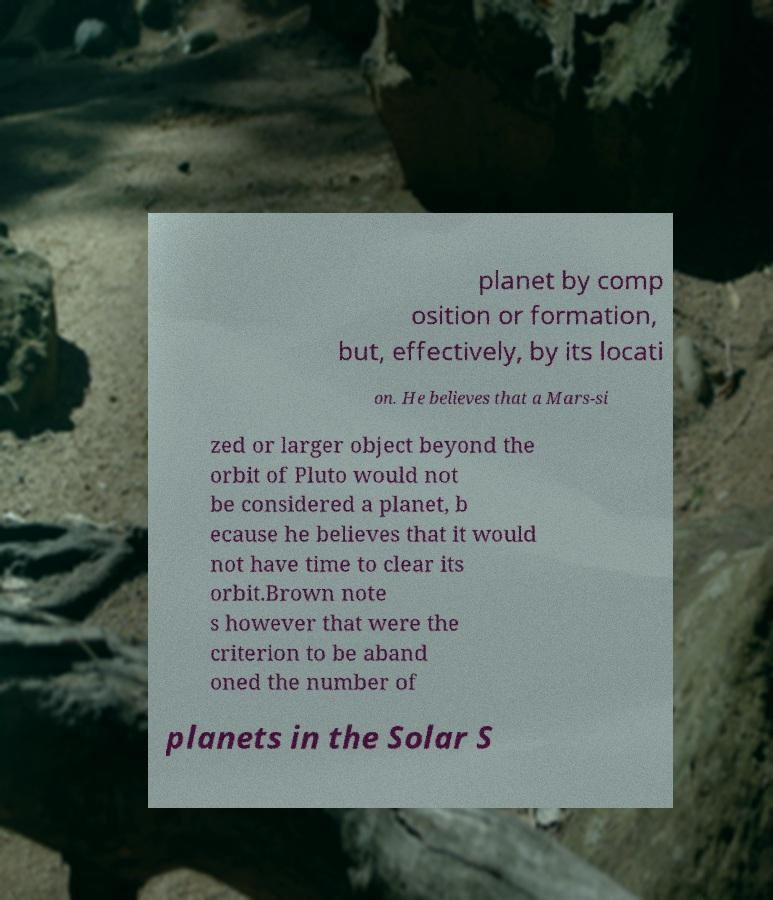There's text embedded in this image that I need extracted. Can you transcribe it verbatim? planet by comp osition or formation, but, effectively, by its locati on. He believes that a Mars-si zed or larger object beyond the orbit of Pluto would not be considered a planet, b ecause he believes that it would not have time to clear its orbit.Brown note s however that were the criterion to be aband oned the number of planets in the Solar S 